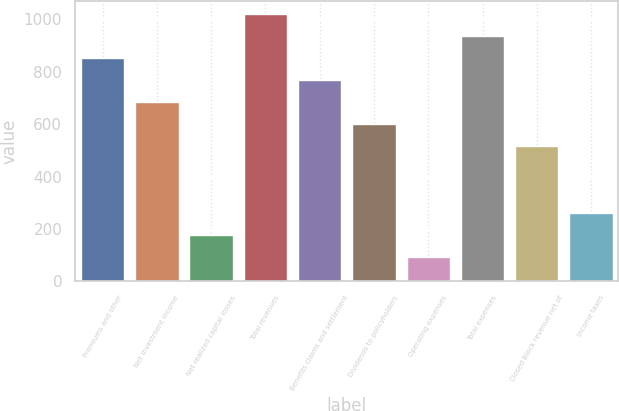Convert chart. <chart><loc_0><loc_0><loc_500><loc_500><bar_chart><fcel>Premiums and other<fcel>Net investment income<fcel>Net realized capital losses<fcel>Total revenues<fcel>Benefits claims and settlement<fcel>Dividends to policyholders<fcel>Operating expenses<fcel>Total expenses<fcel>Closed Block revenue net of<fcel>Income taxes<nl><fcel>852<fcel>683.48<fcel>177.92<fcel>1020.52<fcel>767.74<fcel>599.22<fcel>93.66<fcel>936.26<fcel>514.96<fcel>262.18<nl></chart> 